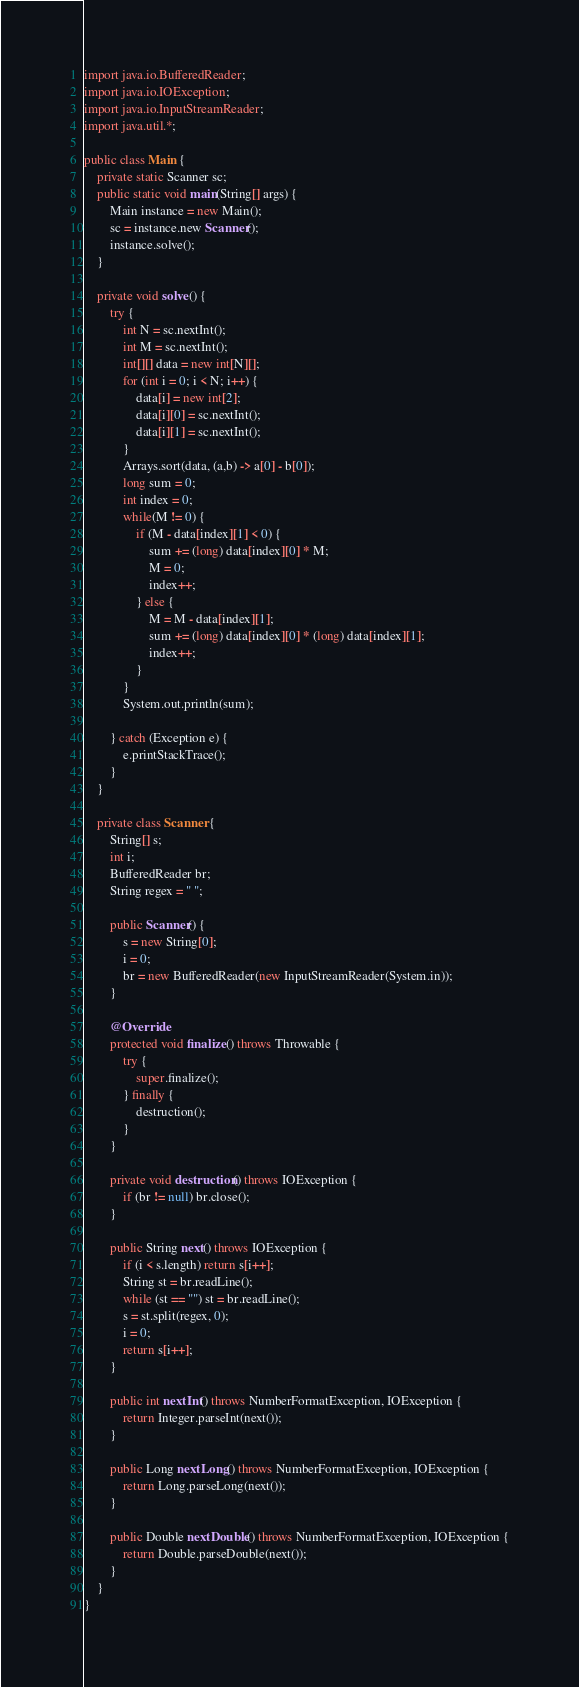<code> <loc_0><loc_0><loc_500><loc_500><_Java_>import java.io.BufferedReader;
import java.io.IOException;
import java.io.InputStreamReader;
import java.util.*;

public class Main {
    private static Scanner sc;
    public static void main(String[] args) {
        Main instance = new Main();
        sc = instance.new Scanner();
        instance.solve();
    }

    private void solve() {
        try {
            int N = sc.nextInt();
            int M = sc.nextInt();
            int[][] data = new int[N][];
            for (int i = 0; i < N; i++) {
                data[i] = new int[2];
                data[i][0] = sc.nextInt();
                data[i][1] = sc.nextInt();
            }
            Arrays.sort(data, (a,b) -> a[0] - b[0]);
            long sum = 0;
            int index = 0;
            while(M != 0) {
                if (M - data[index][1] < 0) {
                    sum += (long) data[index][0] * M;
                    M = 0;
                    index++;
                } else {
                    M = M - data[index][1];
                    sum += (long) data[index][0] * (long) data[index][1];
                    index++;
                }
            }
            System.out.println(sum);

        } catch (Exception e) {
            e.printStackTrace();
        }
    }

    private class Scanner {
        String[] s;
        int i;
        BufferedReader br;
        String regex = " ";

        public Scanner() {
            s = new String[0];
            i = 0;
            br = new BufferedReader(new InputStreamReader(System.in));
        }

        @Override
        protected void finalize() throws Throwable {
            try {
                super.finalize();
            } finally {
                destruction();
            }
        }

        private void destruction() throws IOException {
            if (br != null) br.close();
        }

        public String next() throws IOException {
            if (i < s.length) return s[i++];
            String st = br.readLine();
            while (st == "") st = br.readLine();
            s = st.split(regex, 0);
            i = 0;
            return s[i++];
        }

        public int nextInt() throws NumberFormatException, IOException {
            return Integer.parseInt(next());
        }

        public Long nextLong() throws NumberFormatException, IOException {
            return Long.parseLong(next());
        }

        public Double nextDouble() throws NumberFormatException, IOException {
            return Double.parseDouble(next());
        }
    }
}</code> 